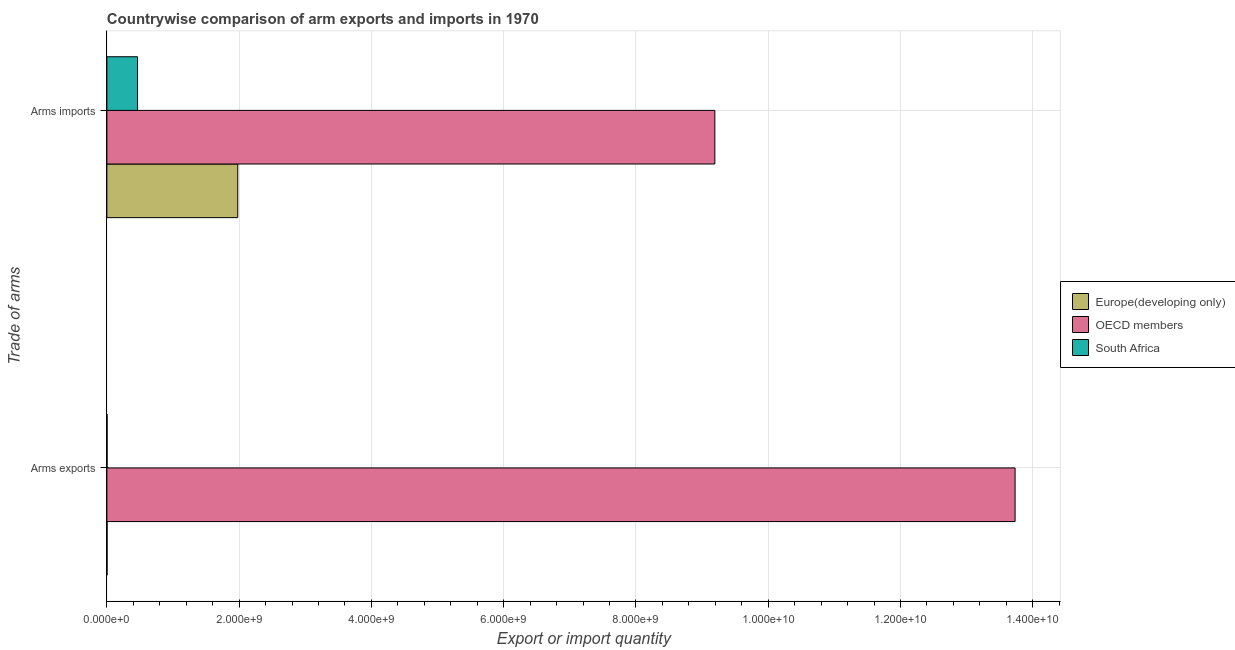Are the number of bars per tick equal to the number of legend labels?
Provide a short and direct response. Yes. Are the number of bars on each tick of the Y-axis equal?
Offer a terse response. Yes. How many bars are there on the 1st tick from the top?
Provide a succinct answer. 3. What is the label of the 2nd group of bars from the top?
Your answer should be very brief. Arms exports. What is the arms exports in Europe(developing only)?
Ensure brevity in your answer.  3.00e+06. Across all countries, what is the maximum arms exports?
Your response must be concise. 1.37e+1. Across all countries, what is the minimum arms imports?
Make the answer very short. 4.64e+08. In which country was the arms imports minimum?
Your answer should be very brief. South Africa. What is the total arms exports in the graph?
Make the answer very short. 1.37e+1. What is the difference between the arms exports in OECD members and the arms imports in Europe(developing only)?
Ensure brevity in your answer.  1.18e+1. What is the average arms exports per country?
Keep it short and to the point. 4.58e+09. What is the difference between the arms exports and arms imports in South Africa?
Keep it short and to the point. -4.61e+08. What is the ratio of the arms exports in OECD members to that in South Africa?
Provide a short and direct response. 4577.67. What does the 1st bar from the top in Arms exports represents?
Ensure brevity in your answer.  South Africa. What does the 1st bar from the bottom in Arms imports represents?
Keep it short and to the point. Europe(developing only). Are all the bars in the graph horizontal?
Make the answer very short. Yes. How many countries are there in the graph?
Your response must be concise. 3. What is the difference between two consecutive major ticks on the X-axis?
Your answer should be compact. 2.00e+09. Does the graph contain any zero values?
Provide a succinct answer. No. Does the graph contain grids?
Your answer should be compact. Yes. Where does the legend appear in the graph?
Keep it short and to the point. Center right. What is the title of the graph?
Provide a succinct answer. Countrywise comparison of arm exports and imports in 1970. What is the label or title of the X-axis?
Your response must be concise. Export or import quantity. What is the label or title of the Y-axis?
Keep it short and to the point. Trade of arms. What is the Export or import quantity of OECD members in Arms exports?
Give a very brief answer. 1.37e+1. What is the Export or import quantity in South Africa in Arms exports?
Make the answer very short. 3.00e+06. What is the Export or import quantity in Europe(developing only) in Arms imports?
Ensure brevity in your answer.  1.98e+09. What is the Export or import quantity in OECD members in Arms imports?
Offer a terse response. 9.19e+09. What is the Export or import quantity of South Africa in Arms imports?
Provide a short and direct response. 4.64e+08. Across all Trade of arms, what is the maximum Export or import quantity in Europe(developing only)?
Give a very brief answer. 1.98e+09. Across all Trade of arms, what is the maximum Export or import quantity in OECD members?
Offer a very short reply. 1.37e+1. Across all Trade of arms, what is the maximum Export or import quantity of South Africa?
Offer a terse response. 4.64e+08. Across all Trade of arms, what is the minimum Export or import quantity in Europe(developing only)?
Offer a very short reply. 3.00e+06. Across all Trade of arms, what is the minimum Export or import quantity of OECD members?
Provide a succinct answer. 9.19e+09. Across all Trade of arms, what is the minimum Export or import quantity in South Africa?
Offer a very short reply. 3.00e+06. What is the total Export or import quantity of Europe(developing only) in the graph?
Offer a terse response. 1.98e+09. What is the total Export or import quantity in OECD members in the graph?
Provide a succinct answer. 2.29e+1. What is the total Export or import quantity in South Africa in the graph?
Provide a short and direct response. 4.67e+08. What is the difference between the Export or import quantity in Europe(developing only) in Arms exports and that in Arms imports?
Your response must be concise. -1.98e+09. What is the difference between the Export or import quantity in OECD members in Arms exports and that in Arms imports?
Provide a succinct answer. 4.54e+09. What is the difference between the Export or import quantity of South Africa in Arms exports and that in Arms imports?
Provide a succinct answer. -4.61e+08. What is the difference between the Export or import quantity of Europe(developing only) in Arms exports and the Export or import quantity of OECD members in Arms imports?
Your response must be concise. -9.19e+09. What is the difference between the Export or import quantity of Europe(developing only) in Arms exports and the Export or import quantity of South Africa in Arms imports?
Offer a terse response. -4.61e+08. What is the difference between the Export or import quantity in OECD members in Arms exports and the Export or import quantity in South Africa in Arms imports?
Give a very brief answer. 1.33e+1. What is the average Export or import quantity in Europe(developing only) per Trade of arms?
Give a very brief answer. 9.91e+08. What is the average Export or import quantity in OECD members per Trade of arms?
Give a very brief answer. 1.15e+1. What is the average Export or import quantity in South Africa per Trade of arms?
Keep it short and to the point. 2.34e+08. What is the difference between the Export or import quantity in Europe(developing only) and Export or import quantity in OECD members in Arms exports?
Give a very brief answer. -1.37e+1. What is the difference between the Export or import quantity of Europe(developing only) and Export or import quantity of South Africa in Arms exports?
Your response must be concise. 0. What is the difference between the Export or import quantity in OECD members and Export or import quantity in South Africa in Arms exports?
Your answer should be compact. 1.37e+1. What is the difference between the Export or import quantity in Europe(developing only) and Export or import quantity in OECD members in Arms imports?
Offer a terse response. -7.21e+09. What is the difference between the Export or import quantity in Europe(developing only) and Export or import quantity in South Africa in Arms imports?
Offer a very short reply. 1.52e+09. What is the difference between the Export or import quantity in OECD members and Export or import quantity in South Africa in Arms imports?
Provide a short and direct response. 8.73e+09. What is the ratio of the Export or import quantity in Europe(developing only) in Arms exports to that in Arms imports?
Give a very brief answer. 0. What is the ratio of the Export or import quantity in OECD members in Arms exports to that in Arms imports?
Give a very brief answer. 1.49. What is the ratio of the Export or import quantity in South Africa in Arms exports to that in Arms imports?
Offer a very short reply. 0.01. What is the difference between the highest and the second highest Export or import quantity of Europe(developing only)?
Give a very brief answer. 1.98e+09. What is the difference between the highest and the second highest Export or import quantity of OECD members?
Make the answer very short. 4.54e+09. What is the difference between the highest and the second highest Export or import quantity in South Africa?
Your answer should be very brief. 4.61e+08. What is the difference between the highest and the lowest Export or import quantity in Europe(developing only)?
Make the answer very short. 1.98e+09. What is the difference between the highest and the lowest Export or import quantity in OECD members?
Provide a short and direct response. 4.54e+09. What is the difference between the highest and the lowest Export or import quantity in South Africa?
Make the answer very short. 4.61e+08. 